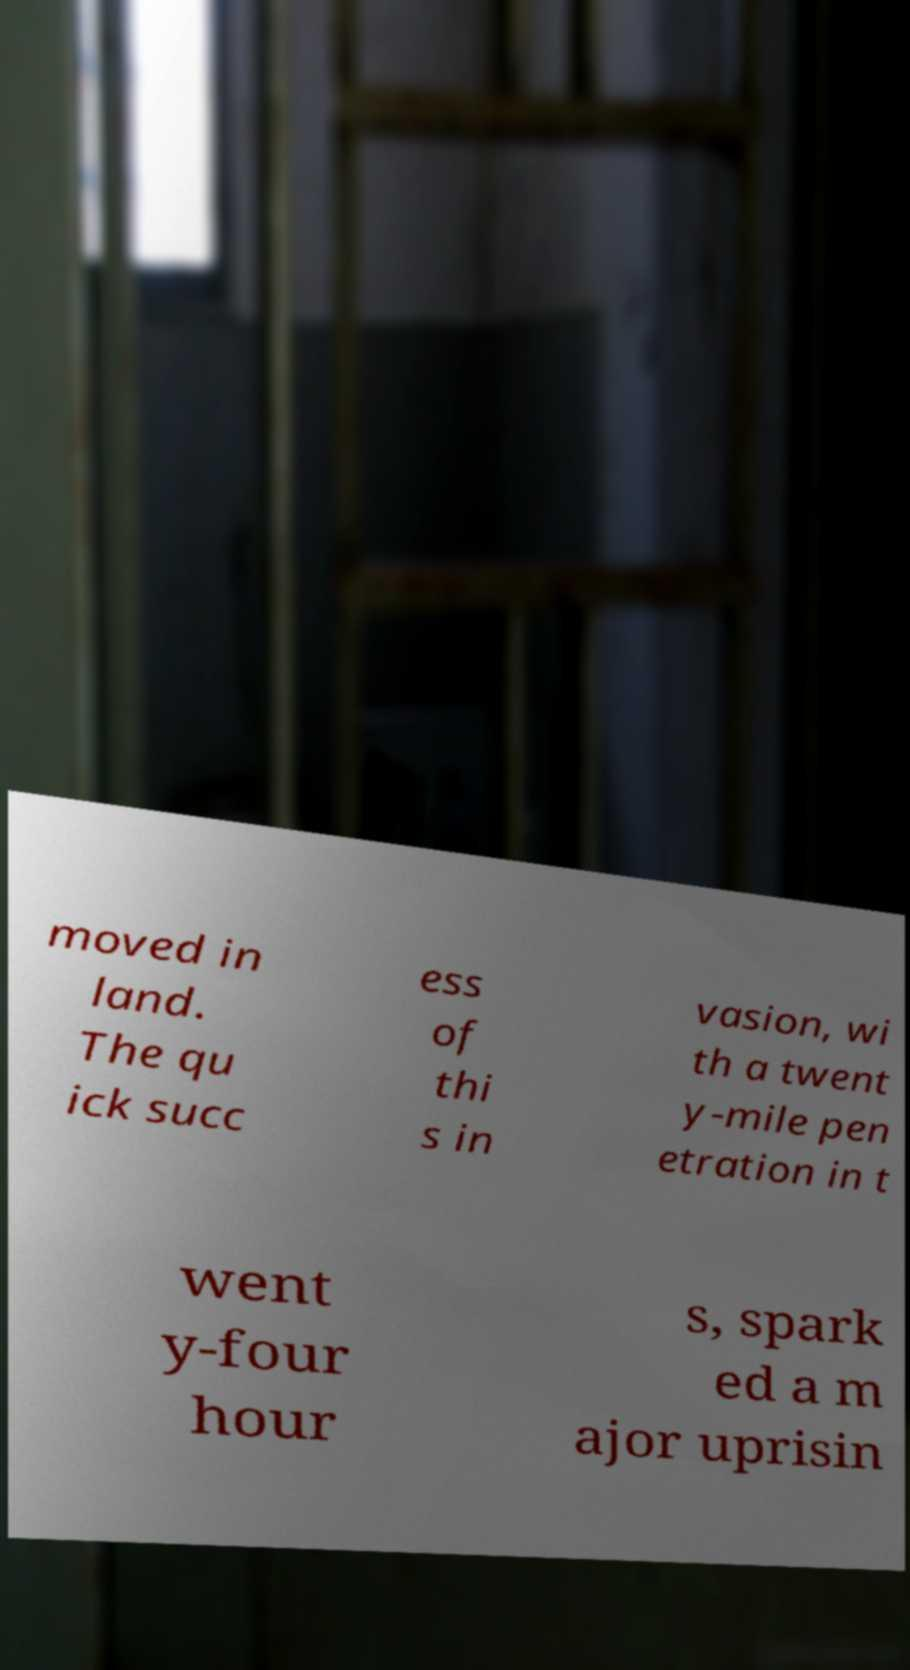Could you extract and type out the text from this image? moved in land. The qu ick succ ess of thi s in vasion, wi th a twent y-mile pen etration in t went y-four hour s, spark ed a m ajor uprisin 